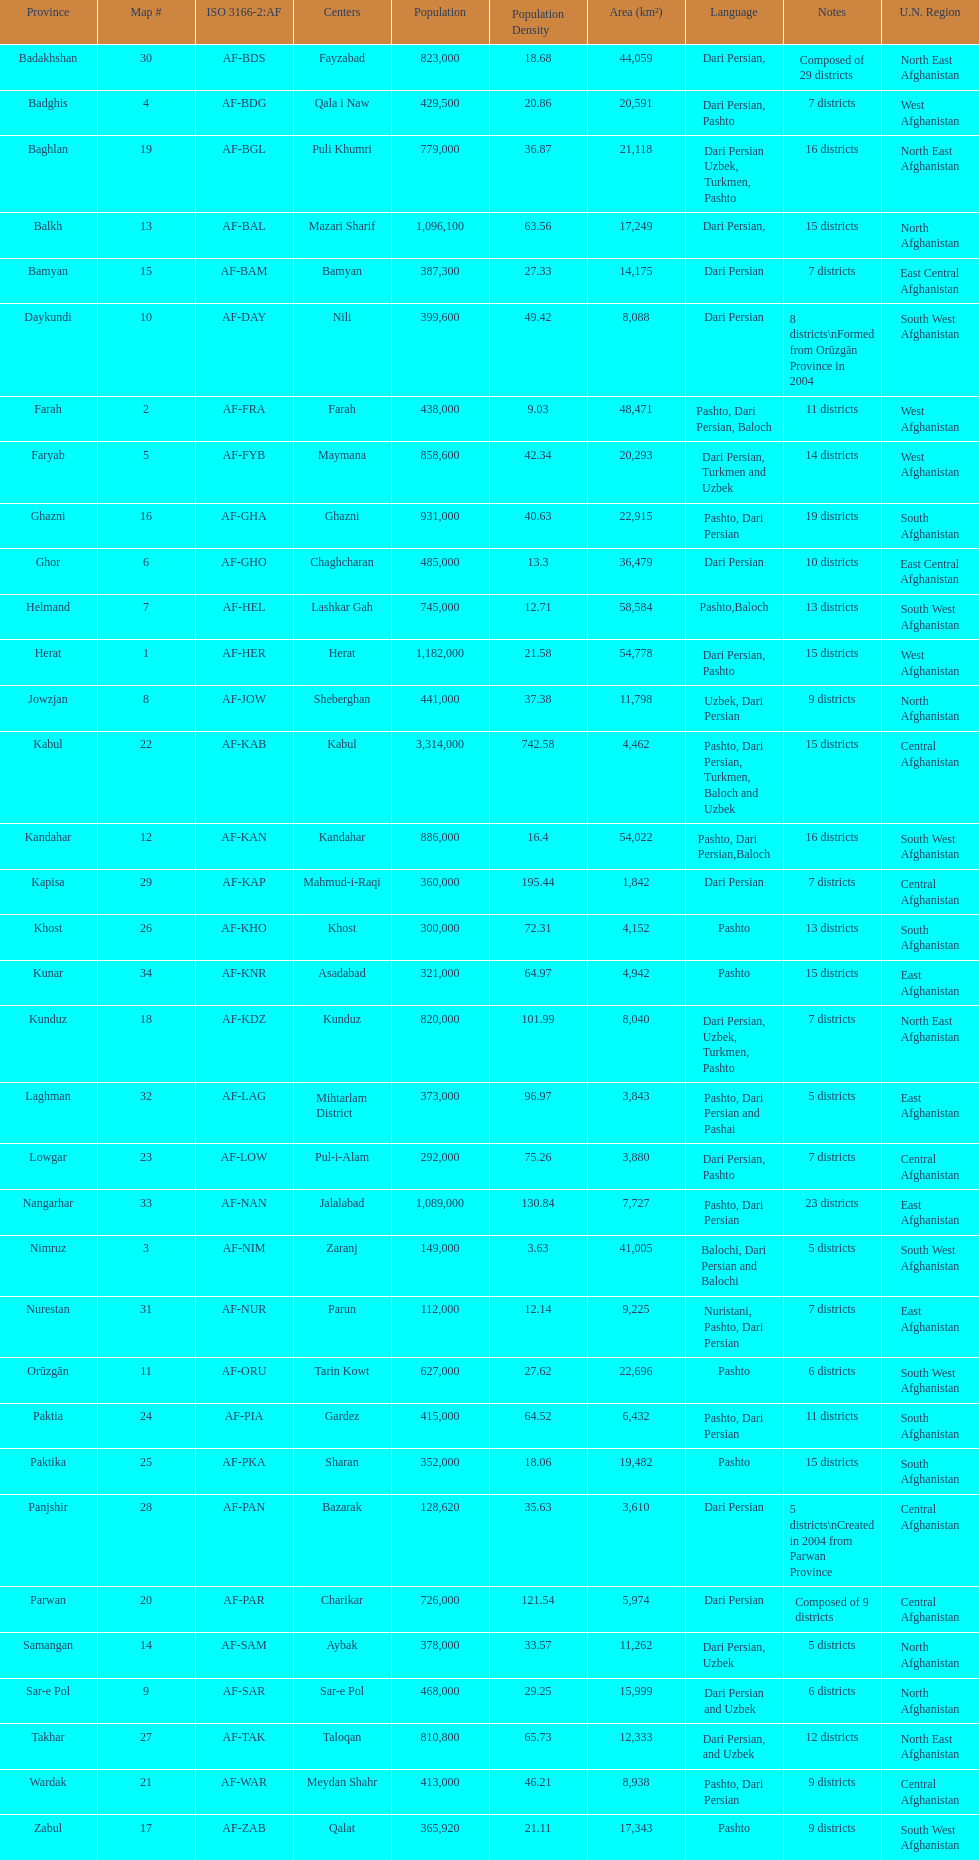Which has a greater number of districts, ghor or farah? Farah. 